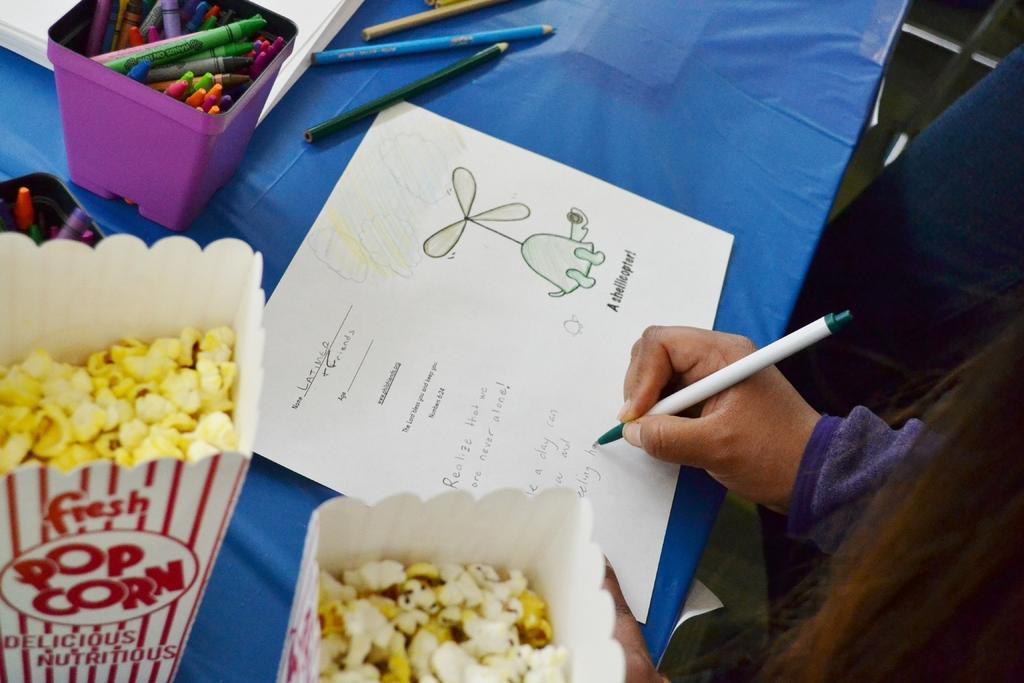Could you give a brief overview of what you see in this image? In the bottom right side of the image a person is standing and holding a pen. In the middle of the image there is a table, on the table there is a paper and pens and popcorn. 